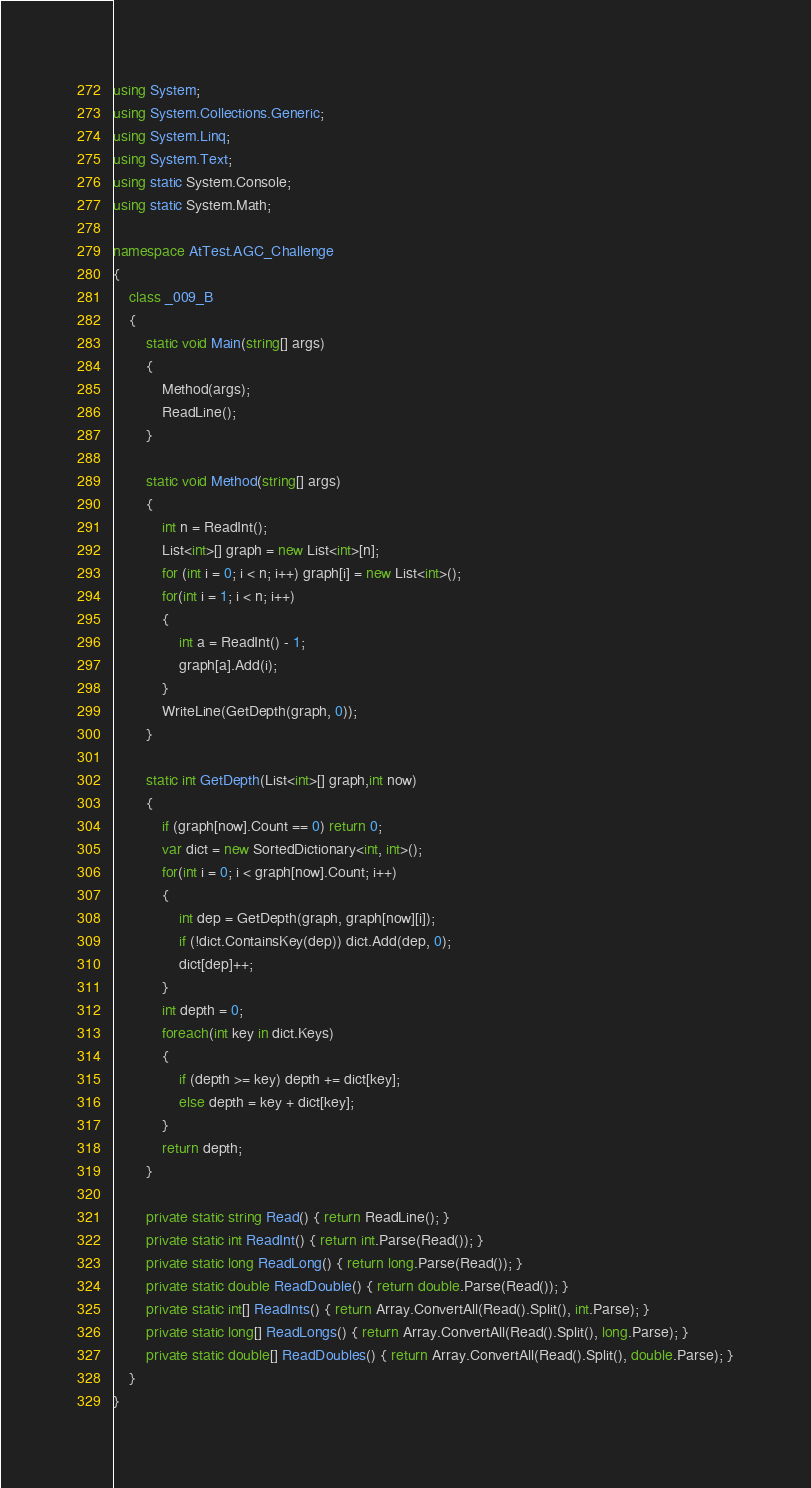Convert code to text. <code><loc_0><loc_0><loc_500><loc_500><_C#_>using System;
using System.Collections.Generic;
using System.Linq;
using System.Text;
using static System.Console;
using static System.Math;

namespace AtTest.AGC_Challenge
{
    class _009_B
    {
        static void Main(string[] args)
        {
            Method(args);
            ReadLine();
        }

        static void Method(string[] args)
        {
            int n = ReadInt();
            List<int>[] graph = new List<int>[n];
            for (int i = 0; i < n; i++) graph[i] = new List<int>();
            for(int i = 1; i < n; i++)
            {
                int a = ReadInt() - 1;
                graph[a].Add(i);
            }
            WriteLine(GetDepth(graph, 0));
        }

        static int GetDepth(List<int>[] graph,int now)
        {
            if (graph[now].Count == 0) return 0;
            var dict = new SortedDictionary<int, int>();
            for(int i = 0; i < graph[now].Count; i++)
            {
                int dep = GetDepth(graph, graph[now][i]);
                if (!dict.ContainsKey(dep)) dict.Add(dep, 0);
                dict[dep]++;
            }
            int depth = 0;
            foreach(int key in dict.Keys)
            {
                if (depth >= key) depth += dict[key];
                else depth = key + dict[key];
            }
            return depth;
        }

        private static string Read() { return ReadLine(); }
        private static int ReadInt() { return int.Parse(Read()); }
        private static long ReadLong() { return long.Parse(Read()); }
        private static double ReadDouble() { return double.Parse(Read()); }
        private static int[] ReadInts() { return Array.ConvertAll(Read().Split(), int.Parse); }
        private static long[] ReadLongs() { return Array.ConvertAll(Read().Split(), long.Parse); }
        private static double[] ReadDoubles() { return Array.ConvertAll(Read().Split(), double.Parse); }
    }
}
</code> 